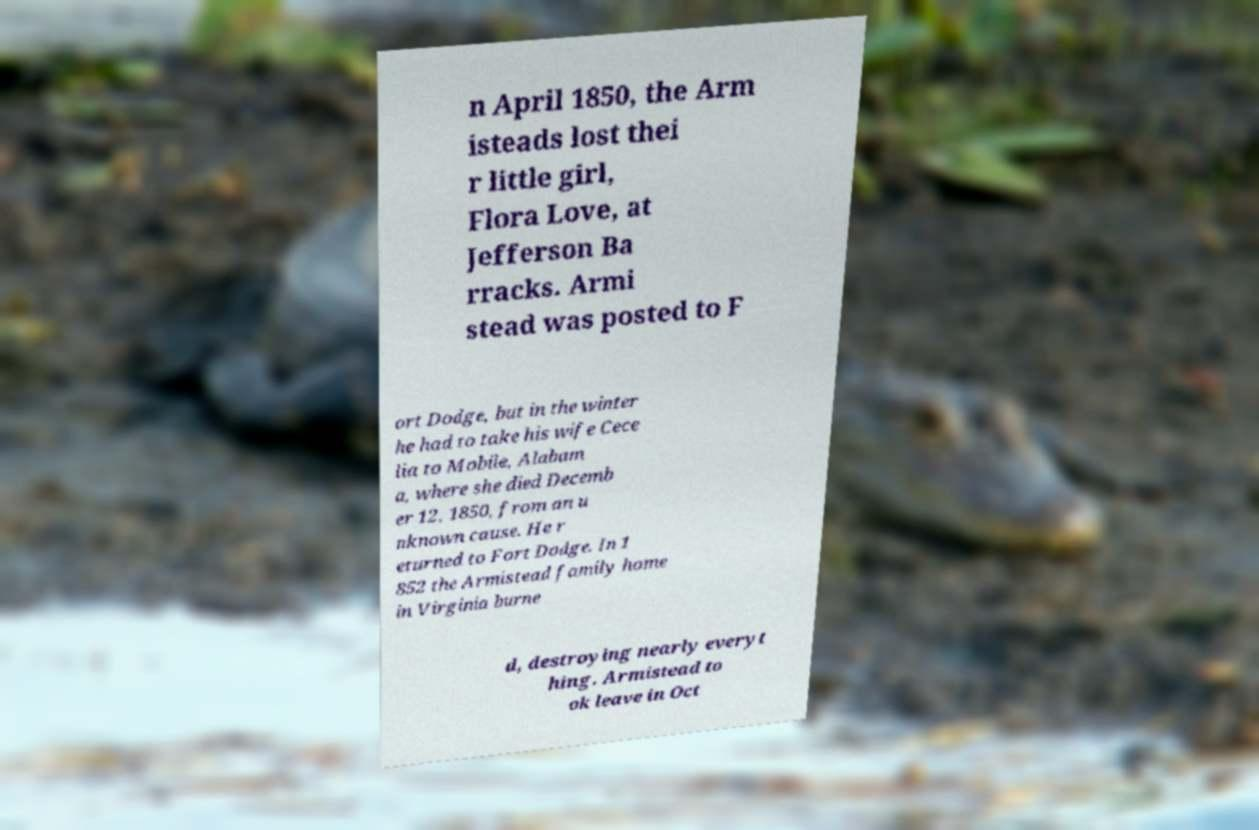What messages or text are displayed in this image? I need them in a readable, typed format. n April 1850, the Arm isteads lost thei r little girl, Flora Love, at Jefferson Ba rracks. Armi stead was posted to F ort Dodge, but in the winter he had to take his wife Cece lia to Mobile, Alabam a, where she died Decemb er 12, 1850, from an u nknown cause. He r eturned to Fort Dodge. In 1 852 the Armistead family home in Virginia burne d, destroying nearly everyt hing. Armistead to ok leave in Oct 